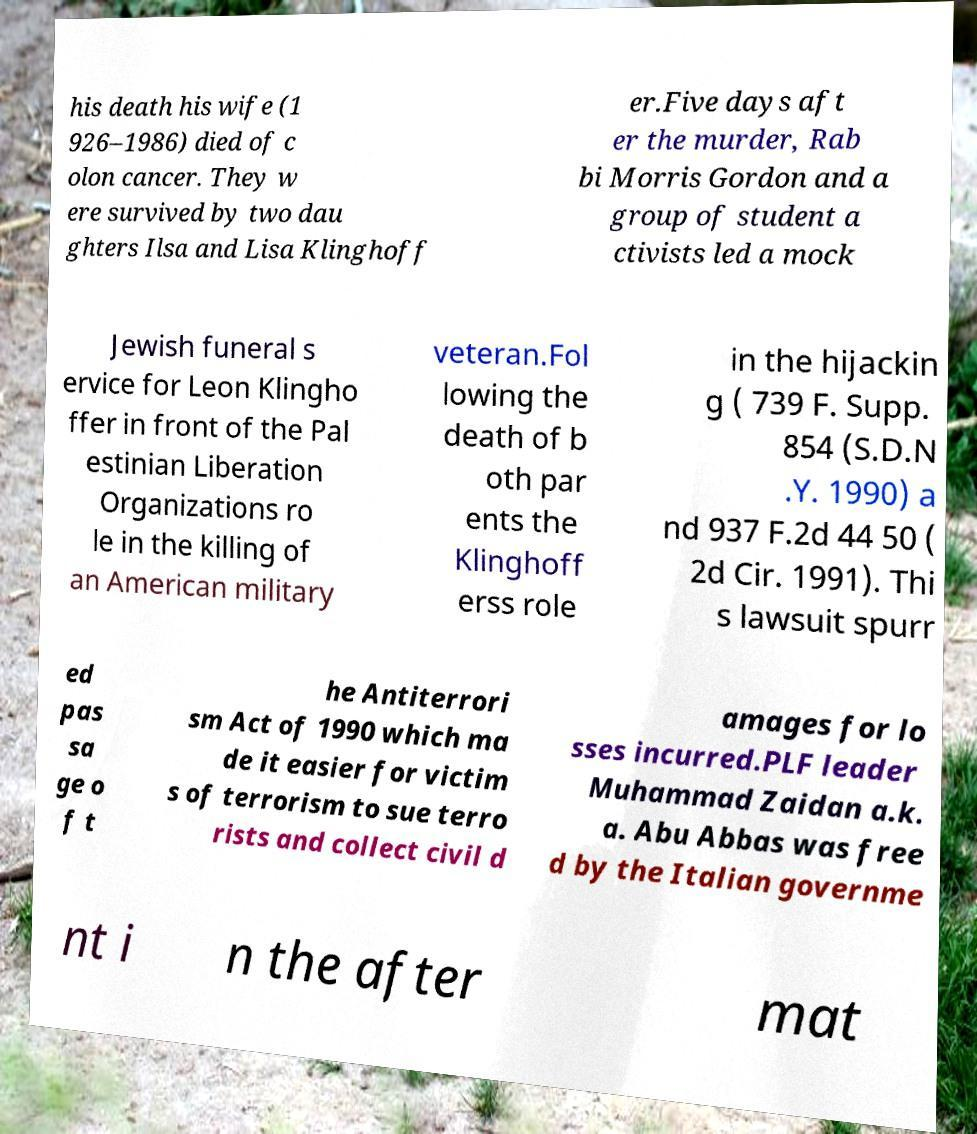Please read and relay the text visible in this image. What does it say? his death his wife (1 926–1986) died of c olon cancer. They w ere survived by two dau ghters Ilsa and Lisa Klinghoff er.Five days aft er the murder, Rab bi Morris Gordon and a group of student a ctivists led a mock Jewish funeral s ervice for Leon Klingho ffer in front of the Pal estinian Liberation Organizations ro le in the killing of an American military veteran.Fol lowing the death of b oth par ents the Klinghoff erss role in the hijackin g ( 739 F. Supp. 854 (S.D.N .Y. 1990) a nd 937 F.2d 44 50 ( 2d Cir. 1991). Thi s lawsuit spurr ed pas sa ge o f t he Antiterrori sm Act of 1990 which ma de it easier for victim s of terrorism to sue terro rists and collect civil d amages for lo sses incurred.PLF leader Muhammad Zaidan a.k. a. Abu Abbas was free d by the Italian governme nt i n the after mat 